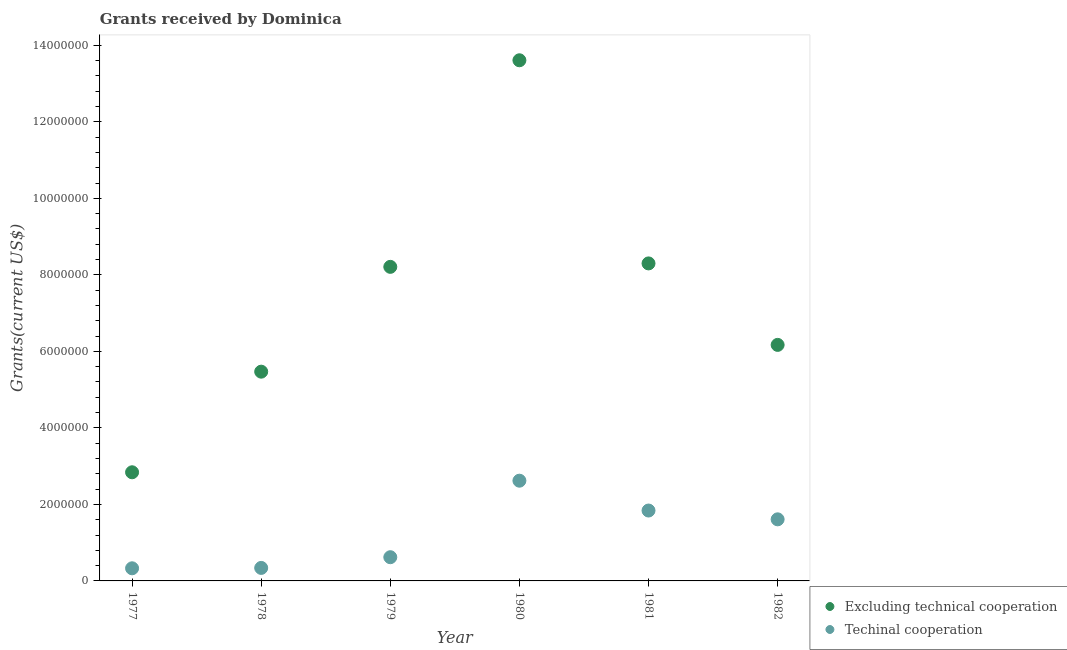Is the number of dotlines equal to the number of legend labels?
Your answer should be compact. Yes. What is the amount of grants received(including technical cooperation) in 1982?
Offer a very short reply. 1.61e+06. Across all years, what is the maximum amount of grants received(excluding technical cooperation)?
Make the answer very short. 1.36e+07. Across all years, what is the minimum amount of grants received(including technical cooperation)?
Make the answer very short. 3.30e+05. In which year was the amount of grants received(including technical cooperation) maximum?
Your answer should be compact. 1980. What is the total amount of grants received(excluding technical cooperation) in the graph?
Your answer should be very brief. 4.46e+07. What is the difference between the amount of grants received(including technical cooperation) in 1978 and that in 1982?
Ensure brevity in your answer.  -1.27e+06. What is the difference between the amount of grants received(excluding technical cooperation) in 1981 and the amount of grants received(including technical cooperation) in 1980?
Ensure brevity in your answer.  5.68e+06. What is the average amount of grants received(excluding technical cooperation) per year?
Offer a very short reply. 7.43e+06. In the year 1979, what is the difference between the amount of grants received(excluding technical cooperation) and amount of grants received(including technical cooperation)?
Your answer should be very brief. 7.59e+06. In how many years, is the amount of grants received(excluding technical cooperation) greater than 8400000 US$?
Provide a short and direct response. 1. What is the ratio of the amount of grants received(including technical cooperation) in 1980 to that in 1981?
Give a very brief answer. 1.42. Is the amount of grants received(excluding technical cooperation) in 1978 less than that in 1980?
Make the answer very short. Yes. Is the difference between the amount of grants received(including technical cooperation) in 1978 and 1980 greater than the difference between the amount of grants received(excluding technical cooperation) in 1978 and 1980?
Offer a terse response. Yes. What is the difference between the highest and the second highest amount of grants received(including technical cooperation)?
Make the answer very short. 7.80e+05. What is the difference between the highest and the lowest amount of grants received(excluding technical cooperation)?
Your answer should be compact. 1.08e+07. How many years are there in the graph?
Offer a terse response. 6. Does the graph contain grids?
Make the answer very short. No. Where does the legend appear in the graph?
Give a very brief answer. Bottom right. What is the title of the graph?
Your answer should be compact. Grants received by Dominica. Does "Domestic liabilities" appear as one of the legend labels in the graph?
Your answer should be very brief. No. What is the label or title of the Y-axis?
Give a very brief answer. Grants(current US$). What is the Grants(current US$) of Excluding technical cooperation in 1977?
Your answer should be very brief. 2.84e+06. What is the Grants(current US$) in Excluding technical cooperation in 1978?
Give a very brief answer. 5.47e+06. What is the Grants(current US$) of Excluding technical cooperation in 1979?
Provide a short and direct response. 8.21e+06. What is the Grants(current US$) of Techinal cooperation in 1979?
Provide a short and direct response. 6.20e+05. What is the Grants(current US$) in Excluding technical cooperation in 1980?
Provide a short and direct response. 1.36e+07. What is the Grants(current US$) in Techinal cooperation in 1980?
Keep it short and to the point. 2.62e+06. What is the Grants(current US$) of Excluding technical cooperation in 1981?
Offer a very short reply. 8.30e+06. What is the Grants(current US$) in Techinal cooperation in 1981?
Offer a very short reply. 1.84e+06. What is the Grants(current US$) in Excluding technical cooperation in 1982?
Offer a very short reply. 6.17e+06. What is the Grants(current US$) of Techinal cooperation in 1982?
Offer a terse response. 1.61e+06. Across all years, what is the maximum Grants(current US$) in Excluding technical cooperation?
Offer a very short reply. 1.36e+07. Across all years, what is the maximum Grants(current US$) in Techinal cooperation?
Make the answer very short. 2.62e+06. Across all years, what is the minimum Grants(current US$) of Excluding technical cooperation?
Your response must be concise. 2.84e+06. Across all years, what is the minimum Grants(current US$) in Techinal cooperation?
Provide a succinct answer. 3.30e+05. What is the total Grants(current US$) in Excluding technical cooperation in the graph?
Offer a terse response. 4.46e+07. What is the total Grants(current US$) of Techinal cooperation in the graph?
Your response must be concise. 7.36e+06. What is the difference between the Grants(current US$) in Excluding technical cooperation in 1977 and that in 1978?
Keep it short and to the point. -2.63e+06. What is the difference between the Grants(current US$) of Techinal cooperation in 1977 and that in 1978?
Ensure brevity in your answer.  -10000. What is the difference between the Grants(current US$) in Excluding technical cooperation in 1977 and that in 1979?
Make the answer very short. -5.37e+06. What is the difference between the Grants(current US$) in Excluding technical cooperation in 1977 and that in 1980?
Offer a very short reply. -1.08e+07. What is the difference between the Grants(current US$) of Techinal cooperation in 1977 and that in 1980?
Provide a short and direct response. -2.29e+06. What is the difference between the Grants(current US$) of Excluding technical cooperation in 1977 and that in 1981?
Your response must be concise. -5.46e+06. What is the difference between the Grants(current US$) of Techinal cooperation in 1977 and that in 1981?
Offer a very short reply. -1.51e+06. What is the difference between the Grants(current US$) in Excluding technical cooperation in 1977 and that in 1982?
Ensure brevity in your answer.  -3.33e+06. What is the difference between the Grants(current US$) in Techinal cooperation in 1977 and that in 1982?
Keep it short and to the point. -1.28e+06. What is the difference between the Grants(current US$) in Excluding technical cooperation in 1978 and that in 1979?
Your answer should be very brief. -2.74e+06. What is the difference between the Grants(current US$) in Techinal cooperation in 1978 and that in 1979?
Give a very brief answer. -2.80e+05. What is the difference between the Grants(current US$) in Excluding technical cooperation in 1978 and that in 1980?
Give a very brief answer. -8.14e+06. What is the difference between the Grants(current US$) in Techinal cooperation in 1978 and that in 1980?
Your answer should be very brief. -2.28e+06. What is the difference between the Grants(current US$) of Excluding technical cooperation in 1978 and that in 1981?
Offer a terse response. -2.83e+06. What is the difference between the Grants(current US$) in Techinal cooperation in 1978 and that in 1981?
Provide a succinct answer. -1.50e+06. What is the difference between the Grants(current US$) of Excluding technical cooperation in 1978 and that in 1982?
Offer a very short reply. -7.00e+05. What is the difference between the Grants(current US$) in Techinal cooperation in 1978 and that in 1982?
Provide a short and direct response. -1.27e+06. What is the difference between the Grants(current US$) of Excluding technical cooperation in 1979 and that in 1980?
Offer a very short reply. -5.40e+06. What is the difference between the Grants(current US$) of Techinal cooperation in 1979 and that in 1981?
Ensure brevity in your answer.  -1.22e+06. What is the difference between the Grants(current US$) in Excluding technical cooperation in 1979 and that in 1982?
Keep it short and to the point. 2.04e+06. What is the difference between the Grants(current US$) in Techinal cooperation in 1979 and that in 1982?
Ensure brevity in your answer.  -9.90e+05. What is the difference between the Grants(current US$) of Excluding technical cooperation in 1980 and that in 1981?
Make the answer very short. 5.31e+06. What is the difference between the Grants(current US$) in Techinal cooperation in 1980 and that in 1981?
Make the answer very short. 7.80e+05. What is the difference between the Grants(current US$) of Excluding technical cooperation in 1980 and that in 1982?
Your response must be concise. 7.44e+06. What is the difference between the Grants(current US$) in Techinal cooperation in 1980 and that in 1982?
Your answer should be compact. 1.01e+06. What is the difference between the Grants(current US$) in Excluding technical cooperation in 1981 and that in 1982?
Ensure brevity in your answer.  2.13e+06. What is the difference between the Grants(current US$) in Excluding technical cooperation in 1977 and the Grants(current US$) in Techinal cooperation in 1978?
Offer a terse response. 2.50e+06. What is the difference between the Grants(current US$) in Excluding technical cooperation in 1977 and the Grants(current US$) in Techinal cooperation in 1979?
Offer a terse response. 2.22e+06. What is the difference between the Grants(current US$) of Excluding technical cooperation in 1977 and the Grants(current US$) of Techinal cooperation in 1982?
Offer a very short reply. 1.23e+06. What is the difference between the Grants(current US$) of Excluding technical cooperation in 1978 and the Grants(current US$) of Techinal cooperation in 1979?
Offer a terse response. 4.85e+06. What is the difference between the Grants(current US$) of Excluding technical cooperation in 1978 and the Grants(current US$) of Techinal cooperation in 1980?
Make the answer very short. 2.85e+06. What is the difference between the Grants(current US$) of Excluding technical cooperation in 1978 and the Grants(current US$) of Techinal cooperation in 1981?
Offer a very short reply. 3.63e+06. What is the difference between the Grants(current US$) of Excluding technical cooperation in 1978 and the Grants(current US$) of Techinal cooperation in 1982?
Offer a very short reply. 3.86e+06. What is the difference between the Grants(current US$) in Excluding technical cooperation in 1979 and the Grants(current US$) in Techinal cooperation in 1980?
Make the answer very short. 5.59e+06. What is the difference between the Grants(current US$) of Excluding technical cooperation in 1979 and the Grants(current US$) of Techinal cooperation in 1981?
Ensure brevity in your answer.  6.37e+06. What is the difference between the Grants(current US$) of Excluding technical cooperation in 1979 and the Grants(current US$) of Techinal cooperation in 1982?
Keep it short and to the point. 6.60e+06. What is the difference between the Grants(current US$) of Excluding technical cooperation in 1980 and the Grants(current US$) of Techinal cooperation in 1981?
Provide a short and direct response. 1.18e+07. What is the difference between the Grants(current US$) in Excluding technical cooperation in 1980 and the Grants(current US$) in Techinal cooperation in 1982?
Give a very brief answer. 1.20e+07. What is the difference between the Grants(current US$) in Excluding technical cooperation in 1981 and the Grants(current US$) in Techinal cooperation in 1982?
Provide a succinct answer. 6.69e+06. What is the average Grants(current US$) of Excluding technical cooperation per year?
Your answer should be very brief. 7.43e+06. What is the average Grants(current US$) of Techinal cooperation per year?
Ensure brevity in your answer.  1.23e+06. In the year 1977, what is the difference between the Grants(current US$) in Excluding technical cooperation and Grants(current US$) in Techinal cooperation?
Offer a terse response. 2.51e+06. In the year 1978, what is the difference between the Grants(current US$) in Excluding technical cooperation and Grants(current US$) in Techinal cooperation?
Offer a terse response. 5.13e+06. In the year 1979, what is the difference between the Grants(current US$) of Excluding technical cooperation and Grants(current US$) of Techinal cooperation?
Provide a succinct answer. 7.59e+06. In the year 1980, what is the difference between the Grants(current US$) of Excluding technical cooperation and Grants(current US$) of Techinal cooperation?
Your response must be concise. 1.10e+07. In the year 1981, what is the difference between the Grants(current US$) in Excluding technical cooperation and Grants(current US$) in Techinal cooperation?
Your answer should be very brief. 6.46e+06. In the year 1982, what is the difference between the Grants(current US$) in Excluding technical cooperation and Grants(current US$) in Techinal cooperation?
Offer a very short reply. 4.56e+06. What is the ratio of the Grants(current US$) of Excluding technical cooperation in 1977 to that in 1978?
Provide a succinct answer. 0.52. What is the ratio of the Grants(current US$) of Techinal cooperation in 1977 to that in 1978?
Offer a terse response. 0.97. What is the ratio of the Grants(current US$) in Excluding technical cooperation in 1977 to that in 1979?
Provide a short and direct response. 0.35. What is the ratio of the Grants(current US$) in Techinal cooperation in 1977 to that in 1979?
Your answer should be compact. 0.53. What is the ratio of the Grants(current US$) in Excluding technical cooperation in 1977 to that in 1980?
Offer a terse response. 0.21. What is the ratio of the Grants(current US$) of Techinal cooperation in 1977 to that in 1980?
Provide a short and direct response. 0.13. What is the ratio of the Grants(current US$) in Excluding technical cooperation in 1977 to that in 1981?
Your response must be concise. 0.34. What is the ratio of the Grants(current US$) in Techinal cooperation in 1977 to that in 1981?
Offer a terse response. 0.18. What is the ratio of the Grants(current US$) of Excluding technical cooperation in 1977 to that in 1982?
Your answer should be very brief. 0.46. What is the ratio of the Grants(current US$) in Techinal cooperation in 1977 to that in 1982?
Your response must be concise. 0.2. What is the ratio of the Grants(current US$) in Excluding technical cooperation in 1978 to that in 1979?
Offer a very short reply. 0.67. What is the ratio of the Grants(current US$) in Techinal cooperation in 1978 to that in 1979?
Provide a succinct answer. 0.55. What is the ratio of the Grants(current US$) in Excluding technical cooperation in 1978 to that in 1980?
Offer a terse response. 0.4. What is the ratio of the Grants(current US$) of Techinal cooperation in 1978 to that in 1980?
Your answer should be very brief. 0.13. What is the ratio of the Grants(current US$) of Excluding technical cooperation in 1978 to that in 1981?
Your answer should be very brief. 0.66. What is the ratio of the Grants(current US$) in Techinal cooperation in 1978 to that in 1981?
Ensure brevity in your answer.  0.18. What is the ratio of the Grants(current US$) in Excluding technical cooperation in 1978 to that in 1982?
Provide a succinct answer. 0.89. What is the ratio of the Grants(current US$) of Techinal cooperation in 1978 to that in 1982?
Make the answer very short. 0.21. What is the ratio of the Grants(current US$) in Excluding technical cooperation in 1979 to that in 1980?
Provide a short and direct response. 0.6. What is the ratio of the Grants(current US$) in Techinal cooperation in 1979 to that in 1980?
Provide a succinct answer. 0.24. What is the ratio of the Grants(current US$) of Techinal cooperation in 1979 to that in 1981?
Offer a terse response. 0.34. What is the ratio of the Grants(current US$) of Excluding technical cooperation in 1979 to that in 1982?
Provide a succinct answer. 1.33. What is the ratio of the Grants(current US$) in Techinal cooperation in 1979 to that in 1982?
Your response must be concise. 0.39. What is the ratio of the Grants(current US$) in Excluding technical cooperation in 1980 to that in 1981?
Give a very brief answer. 1.64. What is the ratio of the Grants(current US$) in Techinal cooperation in 1980 to that in 1981?
Your response must be concise. 1.42. What is the ratio of the Grants(current US$) in Excluding technical cooperation in 1980 to that in 1982?
Offer a terse response. 2.21. What is the ratio of the Grants(current US$) in Techinal cooperation in 1980 to that in 1982?
Your answer should be compact. 1.63. What is the ratio of the Grants(current US$) of Excluding technical cooperation in 1981 to that in 1982?
Your response must be concise. 1.35. What is the ratio of the Grants(current US$) of Techinal cooperation in 1981 to that in 1982?
Give a very brief answer. 1.14. What is the difference between the highest and the second highest Grants(current US$) in Excluding technical cooperation?
Your response must be concise. 5.31e+06. What is the difference between the highest and the second highest Grants(current US$) in Techinal cooperation?
Your answer should be very brief. 7.80e+05. What is the difference between the highest and the lowest Grants(current US$) of Excluding technical cooperation?
Offer a terse response. 1.08e+07. What is the difference between the highest and the lowest Grants(current US$) in Techinal cooperation?
Provide a succinct answer. 2.29e+06. 